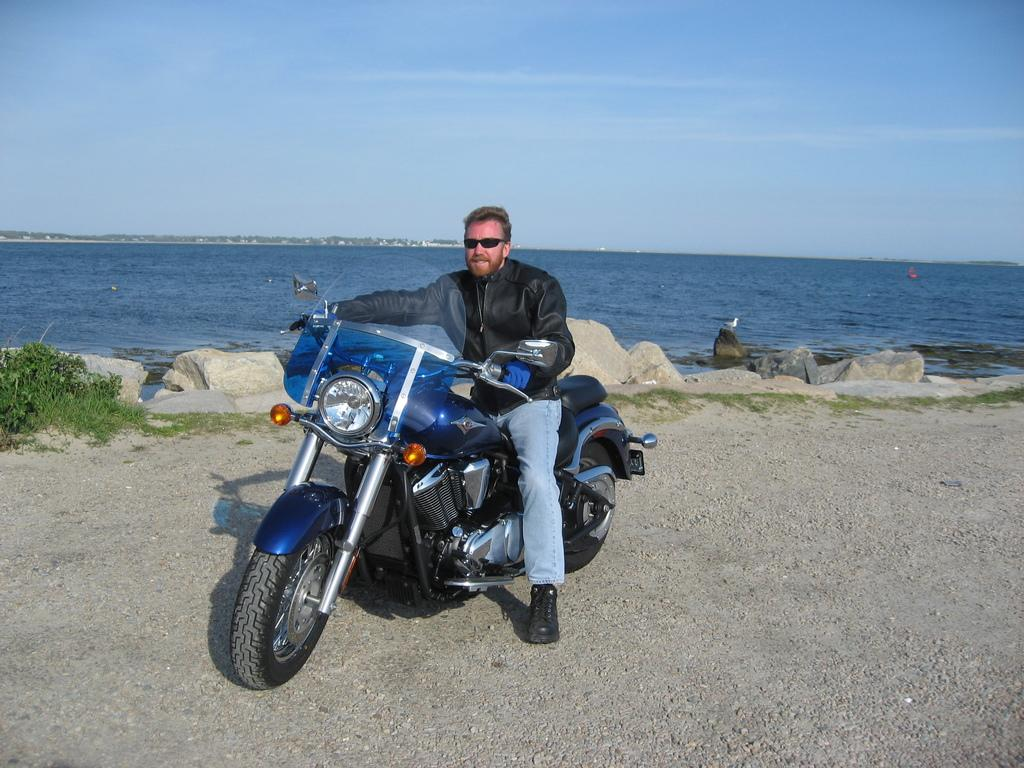What is the person in the image doing? The person is sitting on a motorbike. What can be seen in the background of the image? There is water, plants, rocks, and the sky visible in the background. Can you describe the natural elements present in the image? The image features water, plants, and rocks in the background. What part of the natural environment is visible in the image? The sky is visible in the background of the image. What type of agreement is the person on the motorbike discussing with the spy in the image? There is no spy present in the image, and therefore no discussion about an agreement can be observed. 